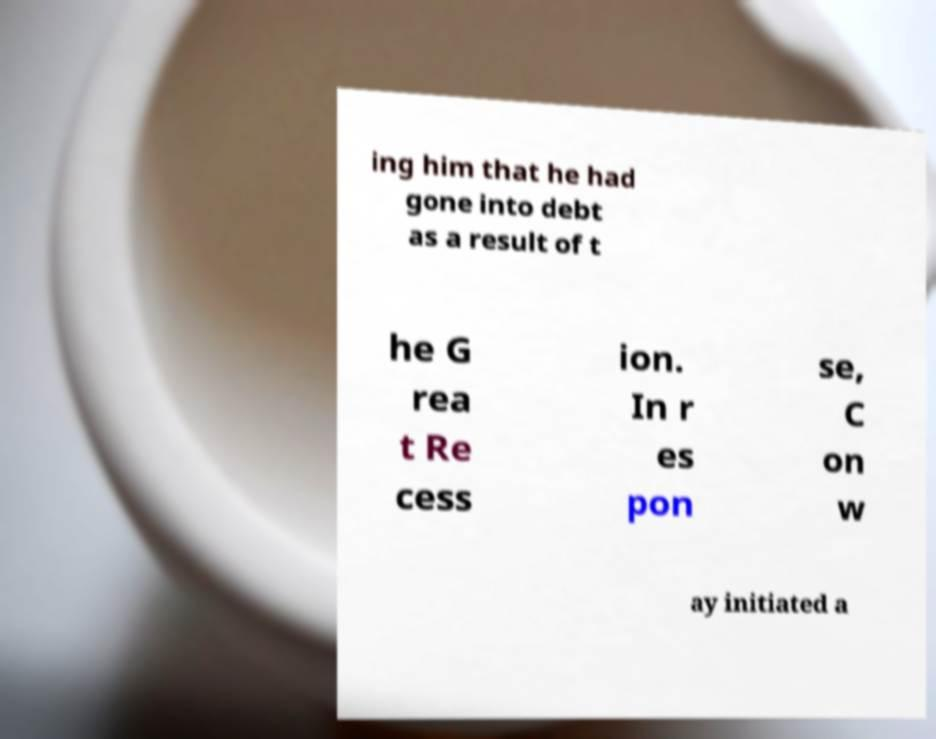For documentation purposes, I need the text within this image transcribed. Could you provide that? ing him that he had gone into debt as a result of t he G rea t Re cess ion. In r es pon se, C on w ay initiated a 